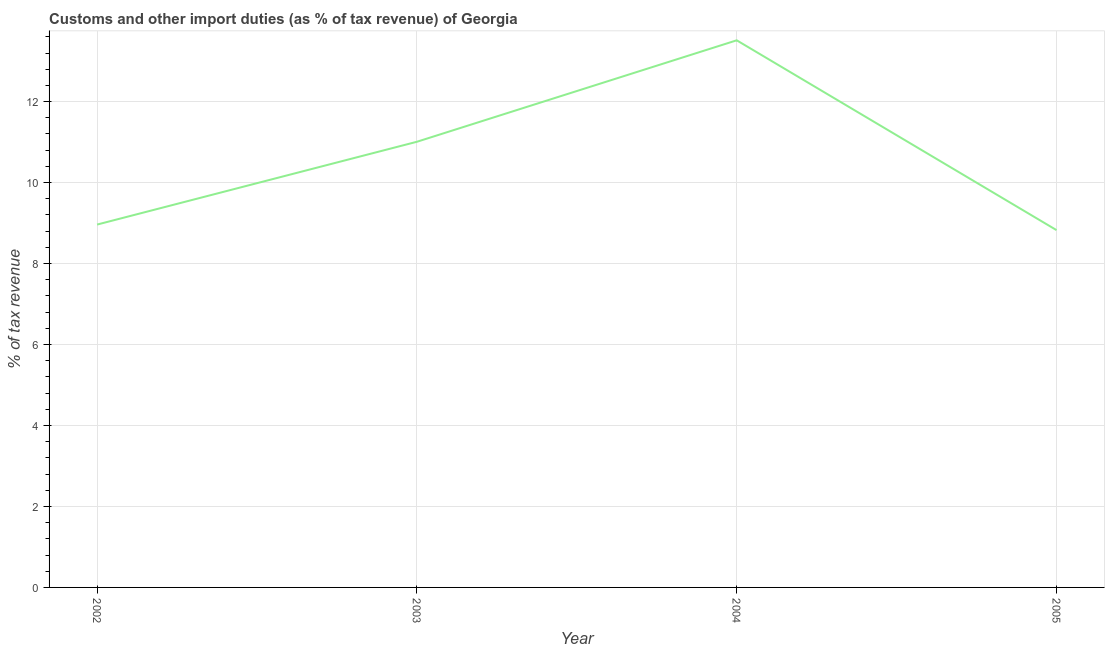What is the customs and other import duties in 2002?
Make the answer very short. 8.96. Across all years, what is the maximum customs and other import duties?
Make the answer very short. 13.51. Across all years, what is the minimum customs and other import duties?
Offer a very short reply. 8.83. In which year was the customs and other import duties minimum?
Offer a terse response. 2005. What is the sum of the customs and other import duties?
Provide a short and direct response. 42.31. What is the difference between the customs and other import duties in 2003 and 2004?
Your answer should be very brief. -2.51. What is the average customs and other import duties per year?
Give a very brief answer. 10.58. What is the median customs and other import duties?
Keep it short and to the point. 9.99. In how many years, is the customs and other import duties greater than 2.4 %?
Offer a very short reply. 4. What is the ratio of the customs and other import duties in 2003 to that in 2005?
Offer a terse response. 1.25. Is the customs and other import duties in 2002 less than that in 2005?
Your answer should be compact. No. What is the difference between the highest and the second highest customs and other import duties?
Your response must be concise. 2.51. Is the sum of the customs and other import duties in 2003 and 2005 greater than the maximum customs and other import duties across all years?
Offer a terse response. Yes. What is the difference between the highest and the lowest customs and other import duties?
Keep it short and to the point. 4.69. In how many years, is the customs and other import duties greater than the average customs and other import duties taken over all years?
Your answer should be compact. 2. Does the customs and other import duties monotonically increase over the years?
Give a very brief answer. No. How many lines are there?
Your answer should be very brief. 1. How many years are there in the graph?
Provide a short and direct response. 4. What is the difference between two consecutive major ticks on the Y-axis?
Offer a terse response. 2. Are the values on the major ticks of Y-axis written in scientific E-notation?
Keep it short and to the point. No. What is the title of the graph?
Offer a terse response. Customs and other import duties (as % of tax revenue) of Georgia. What is the label or title of the Y-axis?
Offer a very short reply. % of tax revenue. What is the % of tax revenue of 2002?
Ensure brevity in your answer.  8.96. What is the % of tax revenue of 2003?
Give a very brief answer. 11.01. What is the % of tax revenue in 2004?
Offer a very short reply. 13.51. What is the % of tax revenue in 2005?
Your answer should be very brief. 8.83. What is the difference between the % of tax revenue in 2002 and 2003?
Your response must be concise. -2.04. What is the difference between the % of tax revenue in 2002 and 2004?
Offer a terse response. -4.55. What is the difference between the % of tax revenue in 2002 and 2005?
Provide a short and direct response. 0.14. What is the difference between the % of tax revenue in 2003 and 2004?
Your answer should be compact. -2.51. What is the difference between the % of tax revenue in 2003 and 2005?
Offer a very short reply. 2.18. What is the difference between the % of tax revenue in 2004 and 2005?
Your answer should be very brief. 4.69. What is the ratio of the % of tax revenue in 2002 to that in 2003?
Offer a terse response. 0.81. What is the ratio of the % of tax revenue in 2002 to that in 2004?
Provide a short and direct response. 0.66. What is the ratio of the % of tax revenue in 2003 to that in 2004?
Give a very brief answer. 0.81. What is the ratio of the % of tax revenue in 2003 to that in 2005?
Provide a succinct answer. 1.25. What is the ratio of the % of tax revenue in 2004 to that in 2005?
Offer a very short reply. 1.53. 